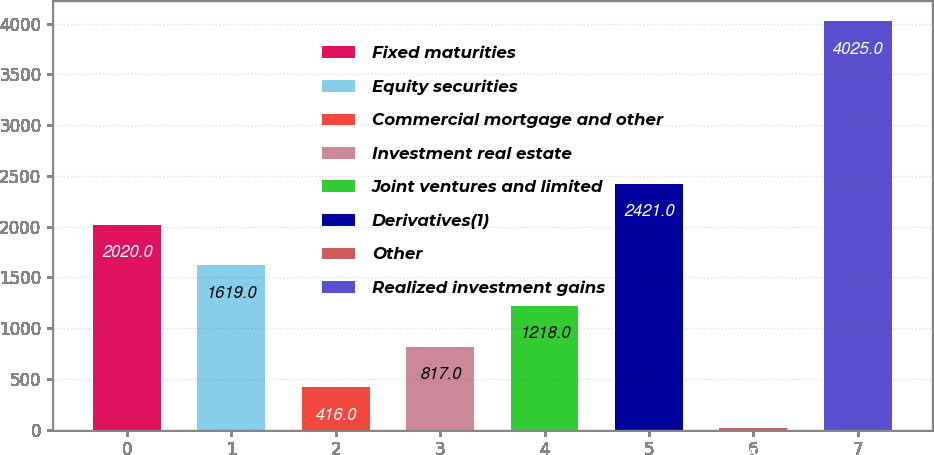Convert chart to OTSL. <chart><loc_0><loc_0><loc_500><loc_500><bar_chart><fcel>Fixed maturities<fcel>Equity securities<fcel>Commercial mortgage and other<fcel>Investment real estate<fcel>Joint ventures and limited<fcel>Derivatives(1)<fcel>Other<fcel>Realized investment gains<nl><fcel>2020<fcel>1619<fcel>416<fcel>817<fcel>1218<fcel>2421<fcel>15<fcel>4025<nl></chart> 